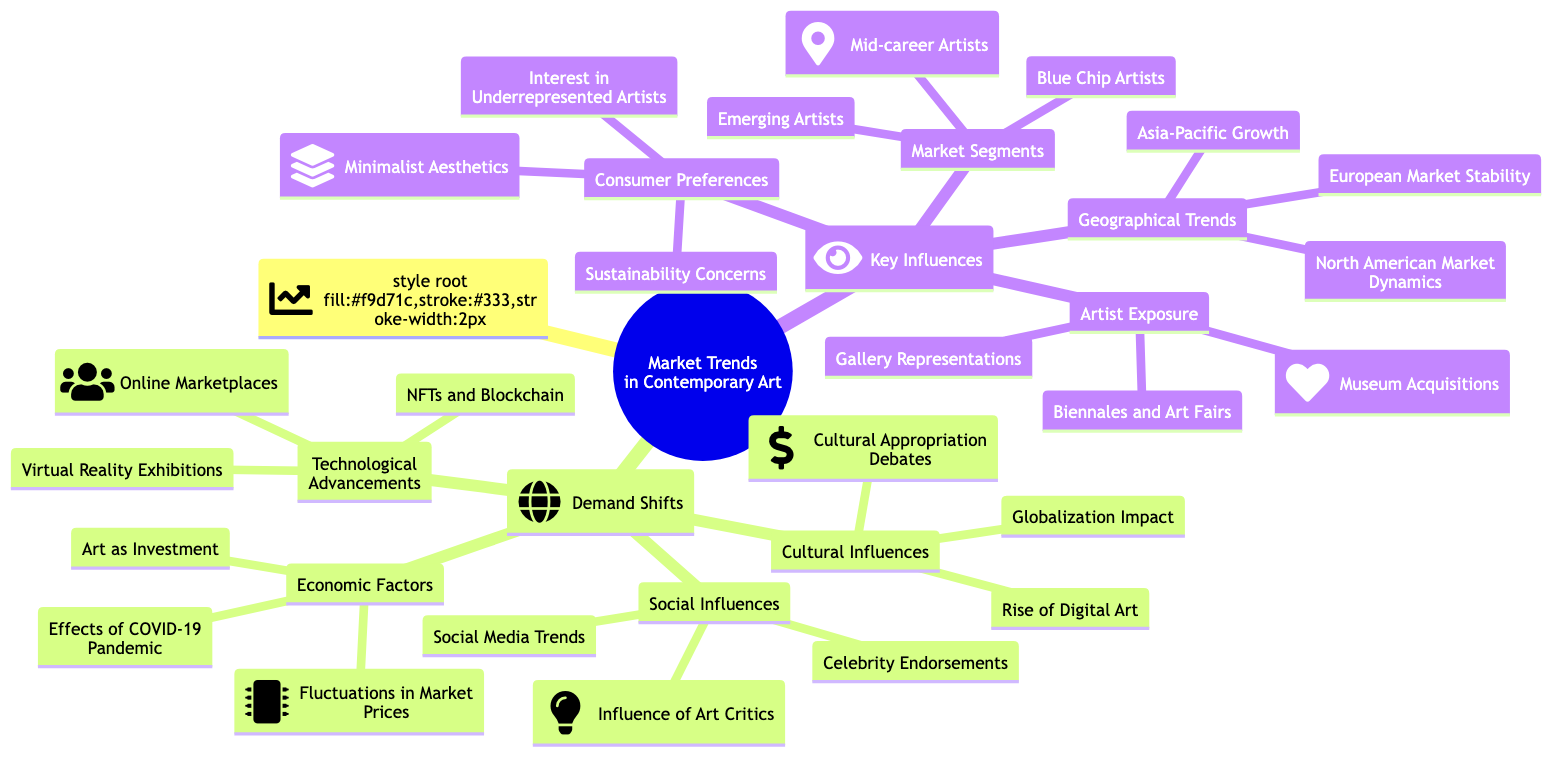What are the three categories under Demand Shifts? The diagram lists Cultural Influences, Economic Factors, and Technological Advancements as the three main categories under Demand Shifts. These categories are represented as child nodes under Demand Shifts in the mind map.
Answer: Cultural Influences, Economic Factors, Technological Advancements Which factor addresses the impact of technology on the art market? The factor that addresses technological impacts is "Technological Advancements," which is one of the main categories listed under Demand Shifts. Within this category, specific elements such as NFTs and Blockchain Technology, Virtual Reality Exhibitions, and Online Marketplaces are mentioned as influences.
Answer: Technological Advancements How many social influences are listed in the diagram? The diagram outlines three social influences, which are Social Media Trends, Celebrity Endorsements, and Influence of Art Critics. By counting these items within the Social Influences section of Demand Shifts, we find there are three listed.
Answer: 3 What market segment is emphasized as emerging? In the Market Segments section under Key Influences, "Emerging Artists" is specifically emphasized as a key segment. This indicates a focus on new talent within the contemporary art scene.
Answer: Emerging Artists How do consumer preferences affect the market? Consumer preferences are guided by factors such as Sustainability Concerns, Interest in Underrepresented Artists, and Minimalist Aesthetics, which all affect the market by influencing what types of art consumers choose to purchase.
Answer: Sustainability Concerns, Interest in Underrepresented Artists, Minimalist Aesthetics What geographical trend indicates growth in the art market? The geographical trend indicating growth in the art market is "Asia-Pacific Growth," which is listed under Geographical Trends in the diagram. This signifies a notable development in that region's art market presence.
Answer: Asia-Pacific Growth What two influences are connected to the demand in contemporary art? The two influences connected to demand in contemporary art are Economic Factors and Cultural Influences, which are both primary categories listed under Demand Shifts. These factors together help to shape the overall demand in the market.
Answer: Economic Factors, Cultural Influences Which technological advancement is particularly associated with market shifts? "NFTs and Blockchain Technology" is the technological advancement particularly associated with market shifts, as it is explicitly listed under the Technological Advancements category in Demand Shifts, indicating its significant impact on the contemporary art scene.
Answer: NFTs and Blockchain Technology What type of artists are represented under the Market Segments? The Market Segments include Emerging Artists, Blue Chip Artists, and Mid-career Artists, categorizing different levels of artist evaluation and their respective market positions in the contemporary art scene.
Answer: Emerging Artists, Blue Chip Artists, Mid-career Artists 